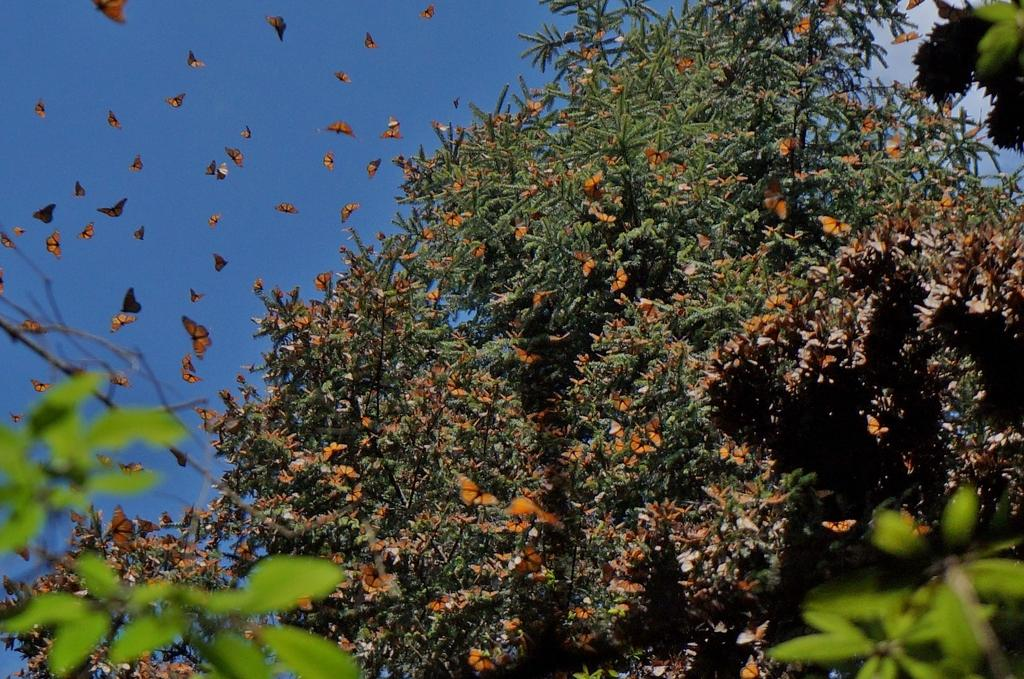What type of animals can be seen in the image? There are butterflies in the image. What type of vegetation is present in the image? There are trees in the image. What color is the sky in the image? The sky is blue in the image. What type of fact can be seen in the image? There is no fact present in the image; it features butterflies, trees, and a blue sky. Is there a band performing in the image? There is no band present in the image. 